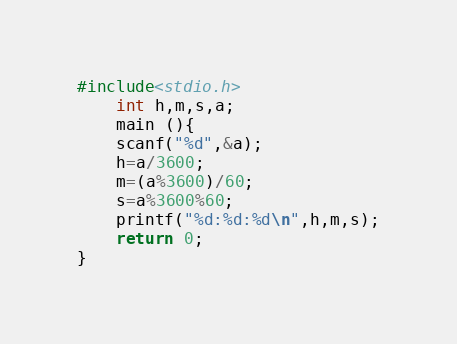<code> <loc_0><loc_0><loc_500><loc_500><_C_>#include<stdio.h>
    int h,m,s,a;
    main (){
    scanf("%d",&a);	
	h=a/3600;
	m=(a%3600)/60;	
	s=a%3600%60;
	printf("%d:%d:%d\n",h,m,s);
	return 0;
}
</code> 